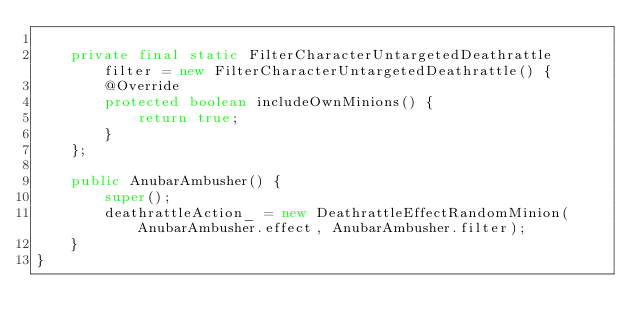Convert code to text. <code><loc_0><loc_0><loc_500><loc_500><_Java_>
    private final static FilterCharacterUntargetedDeathrattle filter = new FilterCharacterUntargetedDeathrattle() {
        @Override
        protected boolean includeOwnMinions() {
            return true;
        }
    };

    public AnubarAmbusher() {
        super();
        deathrattleAction_ = new DeathrattleEffectRandomMinion(AnubarAmbusher.effect, AnubarAmbusher.filter);
    }
}
</code> 